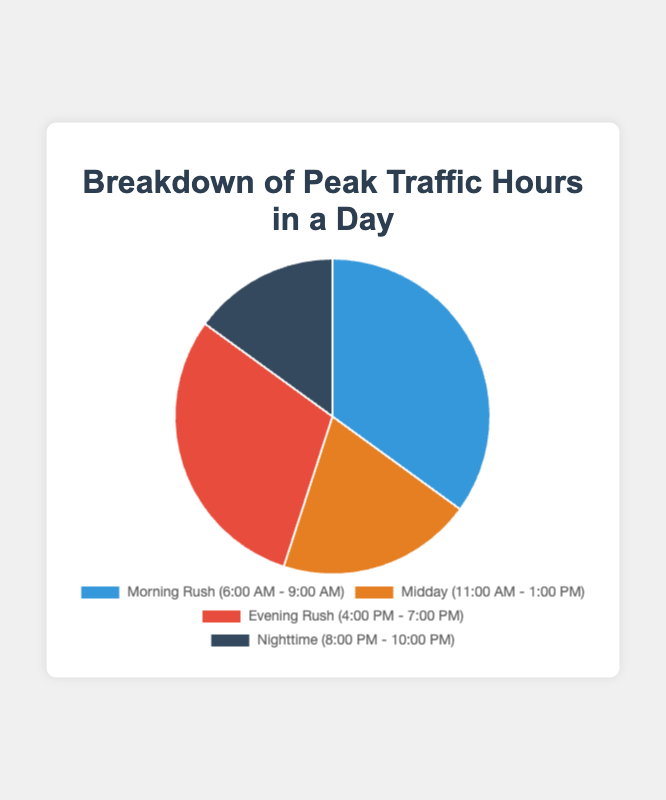Which time period has the highest percentage of peak traffic hours? By looking at the pie chart, the label with the highest percentage value represents the time period with the highest traffic percentage. The "Morning Rush" (6:00 AM - 9:00 AM) has a percentage of 35%, which is the highest.
Answer: Morning Rush (6:00 AM - 9:00 AM) What is the combined percentage of peak traffic hours for the Morning Rush and Evening Rush periods? To find the combined percentage, simply add the percentages of Morning Rush and Evening Rush. Morning Rush is 35% and Evening Rush is 30%. 35% + 30% = 65%.
Answer: 65% Which time period has the smallest percentage of peak traffic hours? By looking at the pie chart, the label with the smallest percentage value represents the time period with the smallest traffic percentage. The "Nighttime" (8:00 PM - 10:00 PM) has a percentage of 15%, which is the smallest.
Answer: Nighttime (8:00 PM - 10:00 PM) How does the percentage of Midday peak traffic compare to Nighttime peak traffic? The percentage for Midday peak traffic is 20%, and the percentage for Nighttime peak traffic is 15%. To compare, we can see that 20% (Midday) is greater than 15% (Nighttime).
Answer: Midday is greater than Nighttime What is the average percentage of the peak traffic periods excluding Nighttime? To find the average, we sum the percentages of the morning rush, midday, and evening rush periods and then divide by the number of periods. Morning Rush is 35%, Midday is 20%, and Evening Rush is 30%. (35 + 20 + 30) / 3 = 28.33%.
Answer: 28.33% What is the difference in percentage between the combined peak traffic periods of Midday and Evening Rush compared to just the Morning Rush? First, find the combined percentage of Midday and Evening Rush: 20% (Midday) + 30% (Evening Rush) = 50%. Then, compare this to the Morning Rush percentage of 35%. The difference is 50% - 35% = 15%.
Answer: 15% Which time period contributing to peak traffic is represented by a blue section in the pie chart? By referring to the colors in the pie chart, the blue section corresponds to the "Morning Rush" time period.
Answer: Morning Rush How many percentage points larger is the Morning Rush compared to the Nighttime traffic period? The Morning Rush has a percentage of 35%, and the Nighttime traffic period has a percentage of 15%. The difference is 35% - 15% = 20 percentage points.
Answer: 20 What is the total percentage of peak traffic covered by all time periods in the chart? The total percentage of a complete pie chart must be 100%, as it represents the whole. By summing the given percentages: 35% (Morning Rush) + 20% (Midday) + 30% (Evening Rush) + 15% (Nighttime) = 100%.
Answer: 100% If the peak traffic periods were adjusted so that Midday and Nighttime both made up 25% each, what would the percentage for the Morning Rush need to be if the Evening Rush percentage remained unchanged? If Midday and Nighttime are both adjusted to 25%, their combined contribution is 25% + 25% = 50%. With Evening Rush still at 30%, the total percentage used is 50% + 30% = 80%. To complete the pie chart to 100%, the Morning Rush would need to be 100% - 80% = 20%.
Answer: 20% 